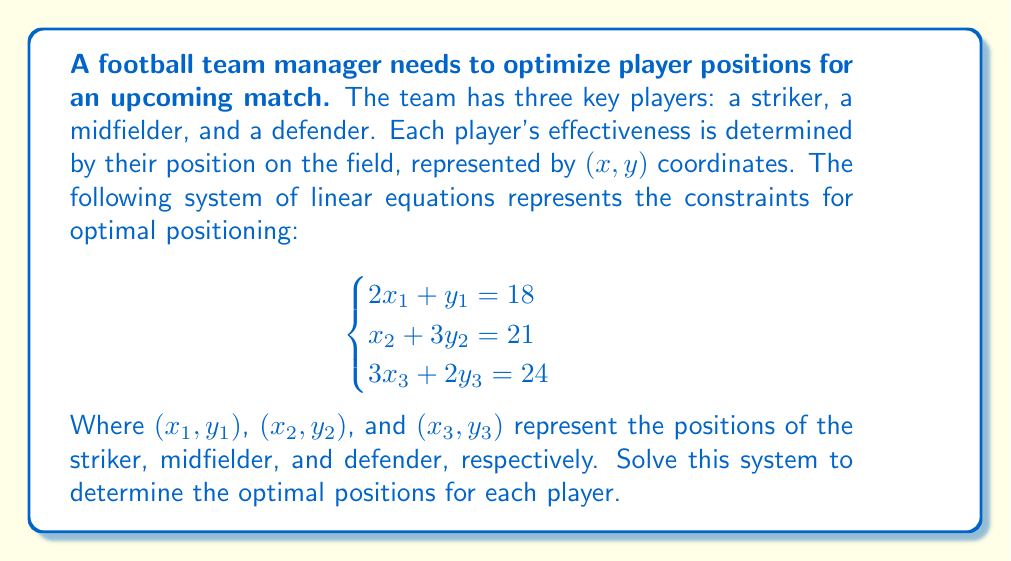What is the answer to this math problem? To solve this system of linear equations, we'll use the substitution method for each equation:

1. For the striker (equation 1):
   $$2x_1 + y_1 = 18$$
   $$y_1 = 18 - 2x_1$$

2. For the midfielder (equation 2):
   $$x_2 + 3y_2 = 21$$
   $$x_2 = 21 - 3y_2$$

3. For the defender (equation 3):
   $$3x_3 + 2y_3 = 24$$
   $$x_3 = 8 - \frac{2}{3}y_3$$

Now, we need to find suitable integer values for each variable that satisfy these equations:

1. Striker: If we choose $x_1 = 6$, then $y_1 = 18 - 2(6) = 6$
   The striker's position is $(6, 6)$

2. Midfielder: If we choose $y_2 = 5$, then $x_2 = 21 - 3(5) = 6$
   The midfielder's position is $(6, 5)$

3. Defender: If we choose $y_3 = 6$, then $x_3 = 8 - \frac{2}{3}(6) = 4$
   The defender's position is $(4, 6)$

We can verify that these solutions satisfy the original equations:

1. $2(6) + 6 = 18$
2. $6 + 3(5) = 21$
3. $3(4) + 2(6) = 24$

Therefore, the optimal positions for each player have been determined.
Answer: Striker: (6, 6), Midfielder: (6, 5), Defender: (4, 6) 